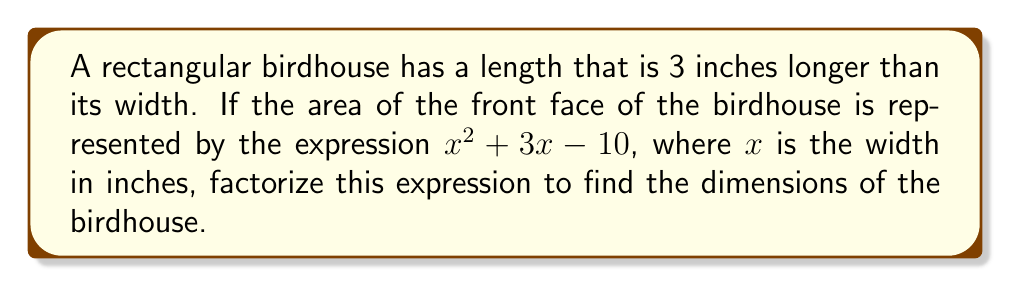Help me with this question. Let's approach this step-by-step:

1) The expression for the area is $x^2 + 3x - 10$, where $x$ is the width.

2) To factorize this quadratic expression, we need to find two numbers that multiply to give the constant term (-10) and add up to give the coefficient of $x$ (3).

3) The factors of -10 are: ±1, ±2, ±5, ±10

4) By inspection, we can see that 5 and -2 satisfy our conditions:
   $5 + (-2) = 3$ and $5 \times (-2) = -10$

5) Therefore, we can rewrite the expression as:
   $x^2 + 3x - 10 = x^2 + 5x - 2x - 10$

6) Grouping these terms:
   $(x^2 + 5x) + (-2x - 10)$

7) Factoring out common factors from each group:
   $x(x + 5) - 2(x + 5)$

8) We can now factor out $(x + 5)$:
   $(x + 5)(x - 2)$

9) Therefore, the factored expression is $(x + 5)(x - 2)$

10) Since $x$ represents the width, and the length is 3 inches longer than the width, we can conclude:
    Width = $x$ inches
    Length = $(x + 3)$ inches

11) From our factorization, we can see that $x$ could be either 2 or -5. Since dimensions can't be negative, $x$ must be 2.

12) Therefore, the final dimensions are:
    Width = 2 inches
    Length = 5 inches
Answer: $(x + 5)(x - 2)$; Width = 2 inches, Length = 5 inches 